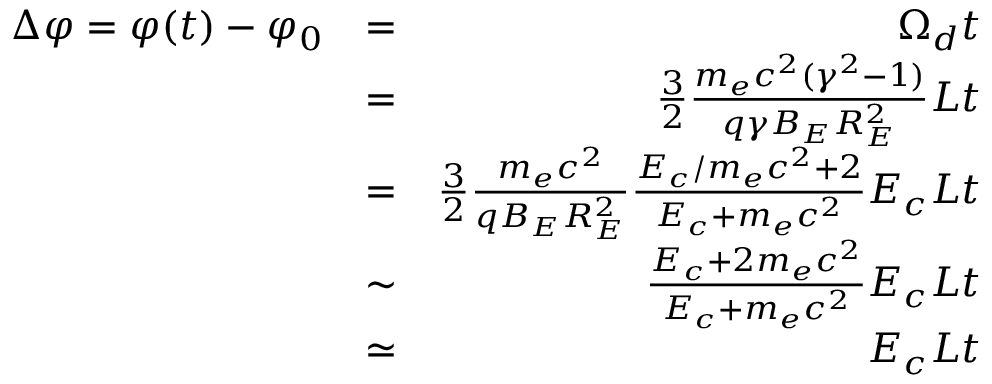Convert formula to latex. <formula><loc_0><loc_0><loc_500><loc_500>\begin{array} { r l r } { \Delta \varphi = \varphi ( t ) - \varphi _ { 0 } } & { = } & { \Omega _ { d } t } \\ & { = } & { \frac { 3 } { 2 } \frac { m _ { e } c ^ { 2 } ( \gamma ^ { 2 } - 1 ) } { q \gamma B _ { E } R _ { E } ^ { 2 } } L t } \\ & { = } & { \frac { 3 } { 2 } \frac { m _ { e } c ^ { 2 } } { { q B _ { E } R _ { E } ^ { 2 } } } \frac { E _ { c } / m _ { e } c ^ { 2 } + 2 } { E _ { c } + m _ { e } c ^ { 2 } } E _ { c } L t } \\ & { \sim } & { \frac { E _ { c } + 2 m _ { e } c ^ { 2 } } { E _ { c } + m _ { e } c ^ { 2 } } E _ { c } L t } \\ & { \simeq } & { E _ { c } L t } \end{array}</formula> 